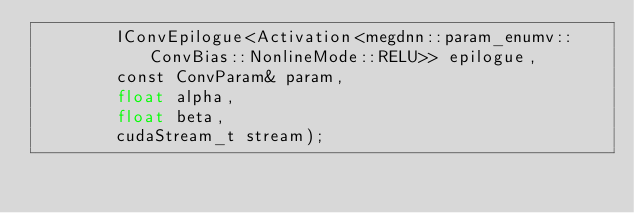<code> <loc_0><loc_0><loc_500><loc_500><_Cuda_>        IConvEpilogue<Activation<megdnn::param_enumv::ConvBias::NonlineMode::RELU>> epilogue, 
        const ConvParam& param, 
        float alpha, 
        float beta, 
        cudaStream_t stream);
</code> 